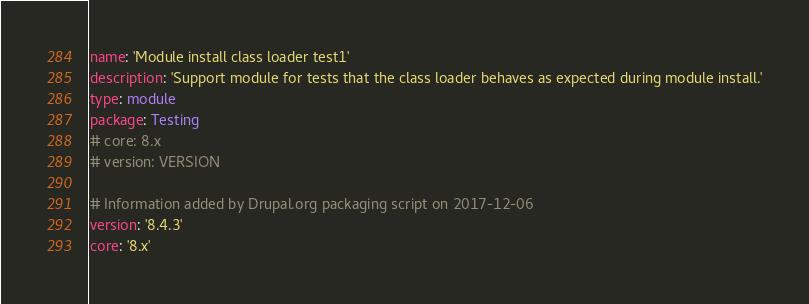<code> <loc_0><loc_0><loc_500><loc_500><_YAML_>name: 'Module install class loader test1'
description: 'Support module for tests that the class loader behaves as expected during module install.'
type: module
package: Testing
# core: 8.x
# version: VERSION

# Information added by Drupal.org packaging script on 2017-12-06
version: '8.4.3'
core: '8.x'</code> 